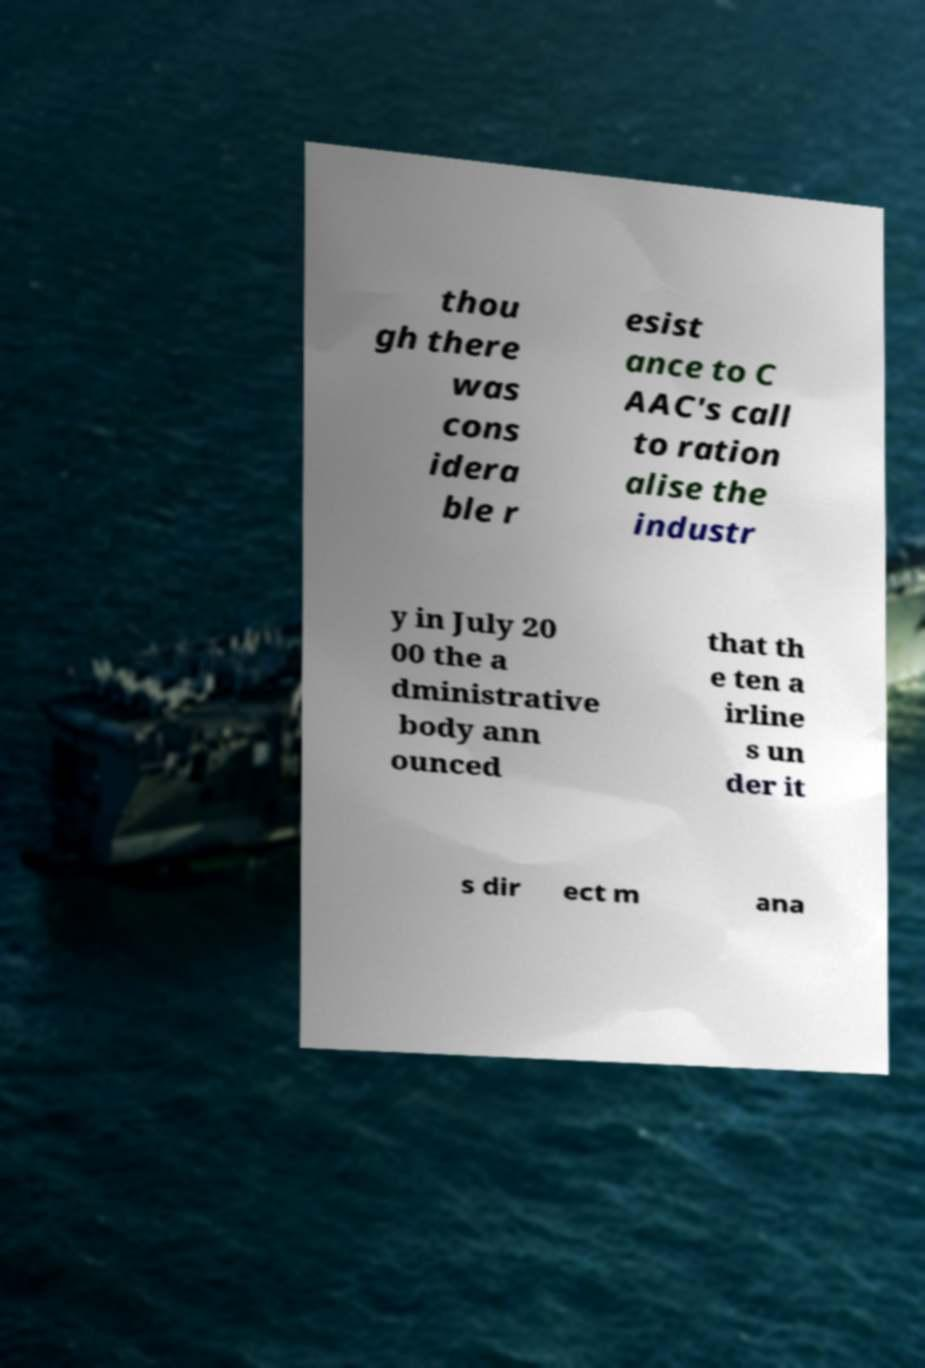For documentation purposes, I need the text within this image transcribed. Could you provide that? thou gh there was cons idera ble r esist ance to C AAC's call to ration alise the industr y in July 20 00 the a dministrative body ann ounced that th e ten a irline s un der it s dir ect m ana 